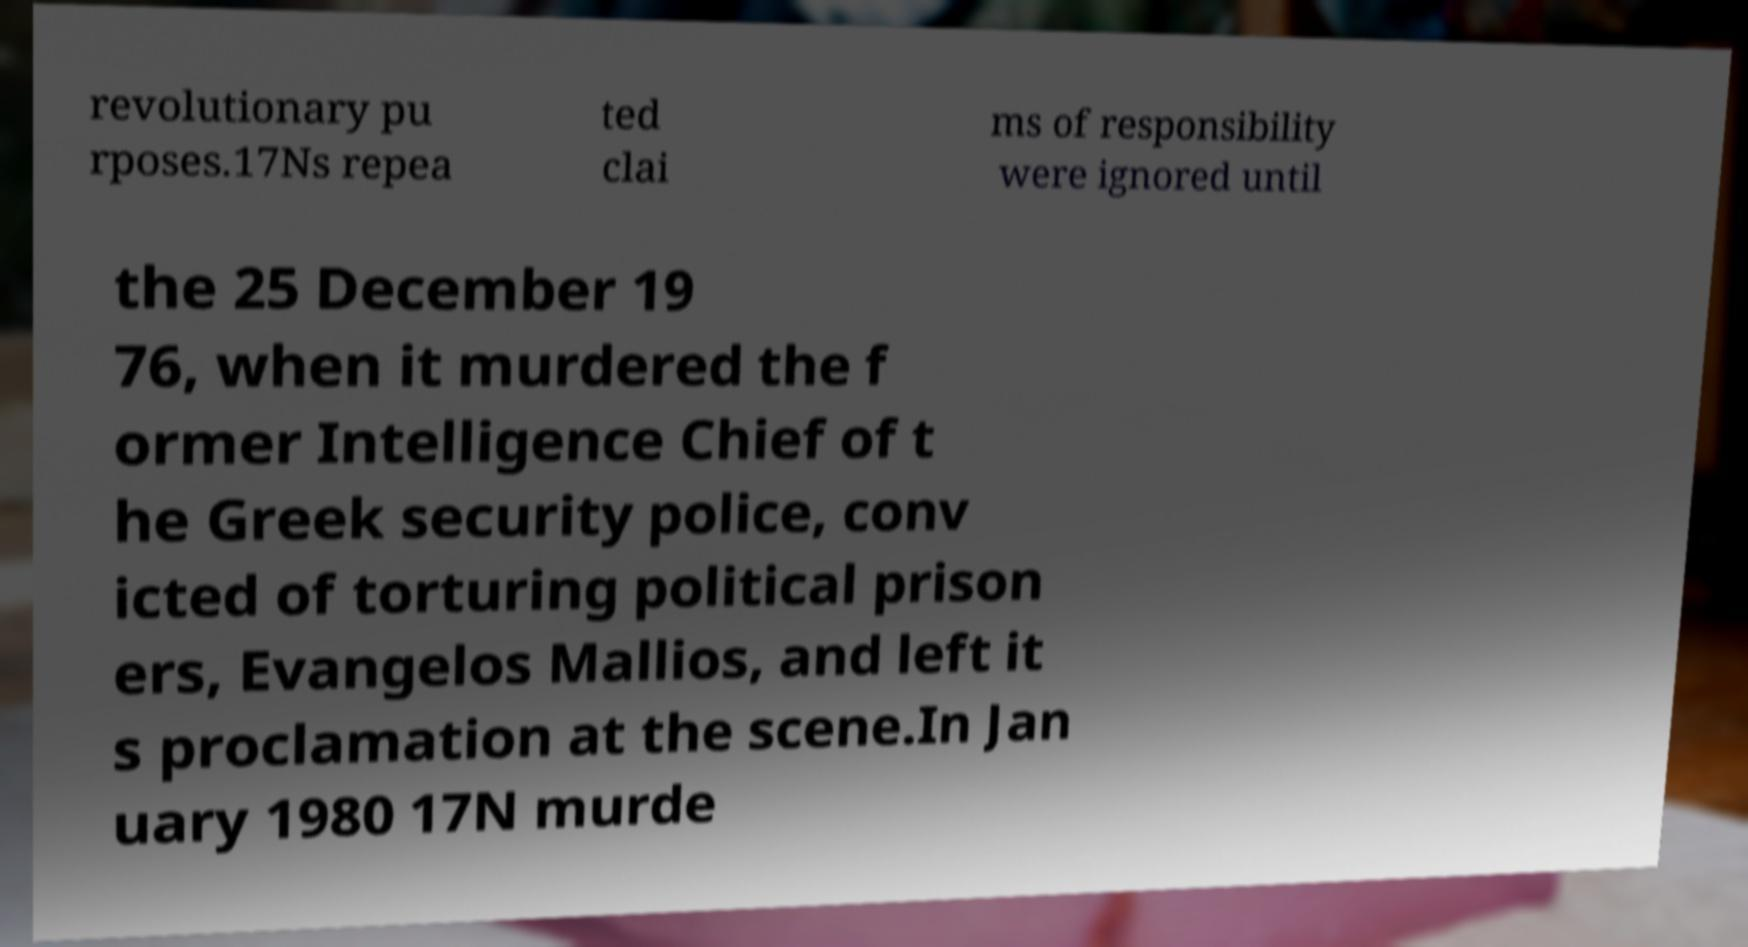For documentation purposes, I need the text within this image transcribed. Could you provide that? revolutionary pu rposes.17Ns repea ted clai ms of responsibility were ignored until the 25 December 19 76, when it murdered the f ormer Intelligence Chief of t he Greek security police, conv icted of torturing political prison ers, Evangelos Mallios, and left it s proclamation at the scene.In Jan uary 1980 17N murde 